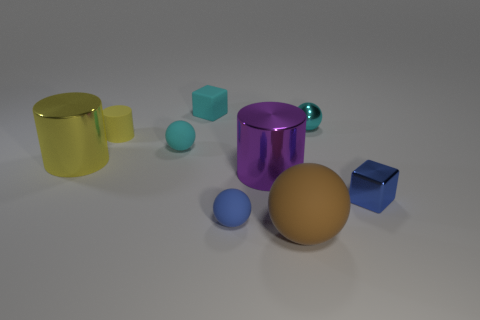Is the shape of the yellow rubber thing the same as the small blue thing left of the small blue shiny cube?
Offer a terse response. No. What size is the ball that is both to the right of the tiny blue ball and in front of the small blue metallic object?
Provide a short and direct response. Large. What number of small blue objects are there?
Make the answer very short. 2. What material is the cyan cube that is the same size as the blue cube?
Keep it short and to the point. Rubber. Are there any other green metal blocks of the same size as the metal block?
Your answer should be very brief. No. Is the color of the matte sphere that is on the right side of the large purple metallic object the same as the cube that is in front of the tiny yellow cylinder?
Your answer should be very brief. No. How many shiny things are either cyan balls or tiny cylinders?
Offer a terse response. 1. There is a small cyan object to the right of the matte ball that is in front of the blue matte thing; how many tiny blue things are left of it?
Provide a short and direct response. 1. What is the size of the blue sphere that is the same material as the tiny cylinder?
Provide a succinct answer. Small. What number of tiny metal spheres are the same color as the tiny cylinder?
Provide a short and direct response. 0. 